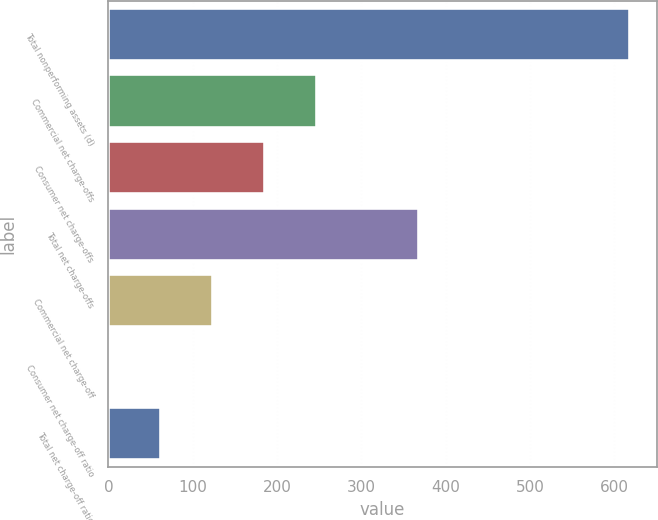<chart> <loc_0><loc_0><loc_500><loc_500><bar_chart><fcel>Total nonperforming assets (d)<fcel>Commercial net charge-offs<fcel>Consumer net charge-offs<fcel>Total net charge-offs<fcel>Commercial net charge-off<fcel>Consumer net charge-off ratio<fcel>Total net charge-off ratio<nl><fcel>619<fcel>247.92<fcel>186.08<fcel>368<fcel>124.24<fcel>0.56<fcel>62.4<nl></chart> 